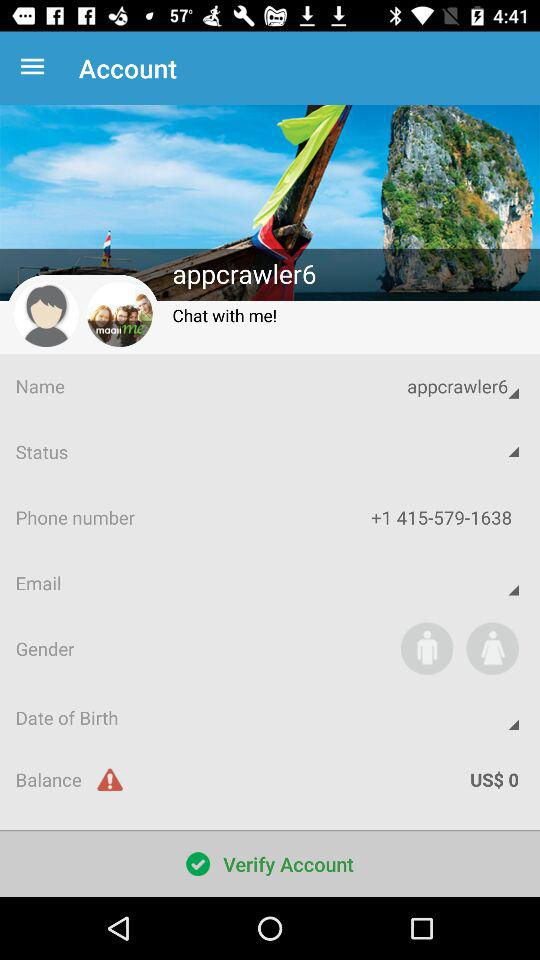What name is used in the account? In the account, the name "appcrawler6" is used. 